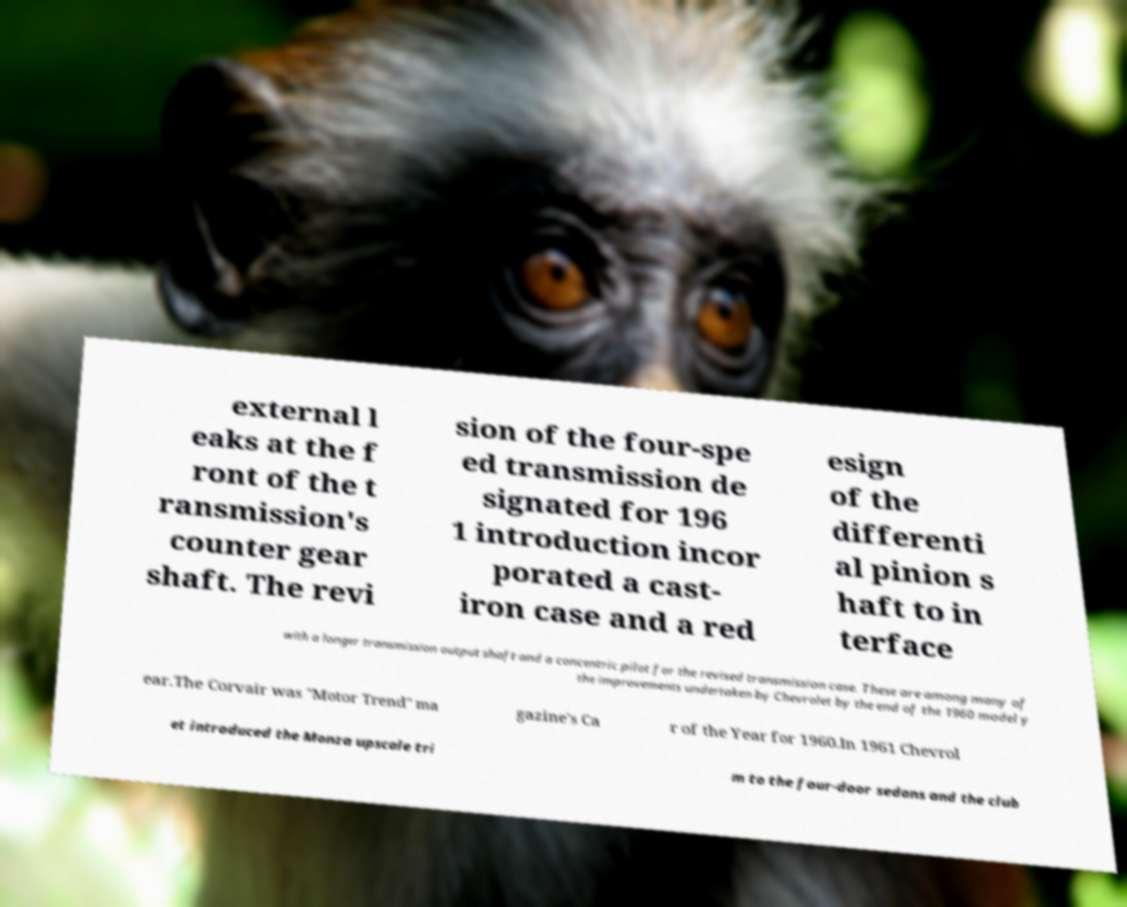Can you read and provide the text displayed in the image?This photo seems to have some interesting text. Can you extract and type it out for me? external l eaks at the f ront of the t ransmission's counter gear shaft. The revi sion of the four-spe ed transmission de signated for 196 1 introduction incor porated a cast- iron case and a red esign of the differenti al pinion s haft to in terface with a longer transmission output shaft and a concentric pilot for the revised transmission case. These are among many of the improvements undertaken by Chevrolet by the end of the 1960 model y ear.The Corvair was "Motor Trend" ma gazine's Ca r of the Year for 1960.In 1961 Chevrol et introduced the Monza upscale tri m to the four-door sedans and the club 